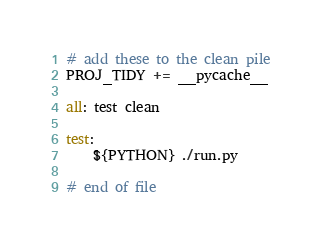<code> <loc_0><loc_0><loc_500><loc_500><_ObjectiveC_>
# add these to the clean pile
PROJ_TIDY += __pycache__

all: test clean

test:
	${PYTHON} ./run.py

# end of file
</code> 